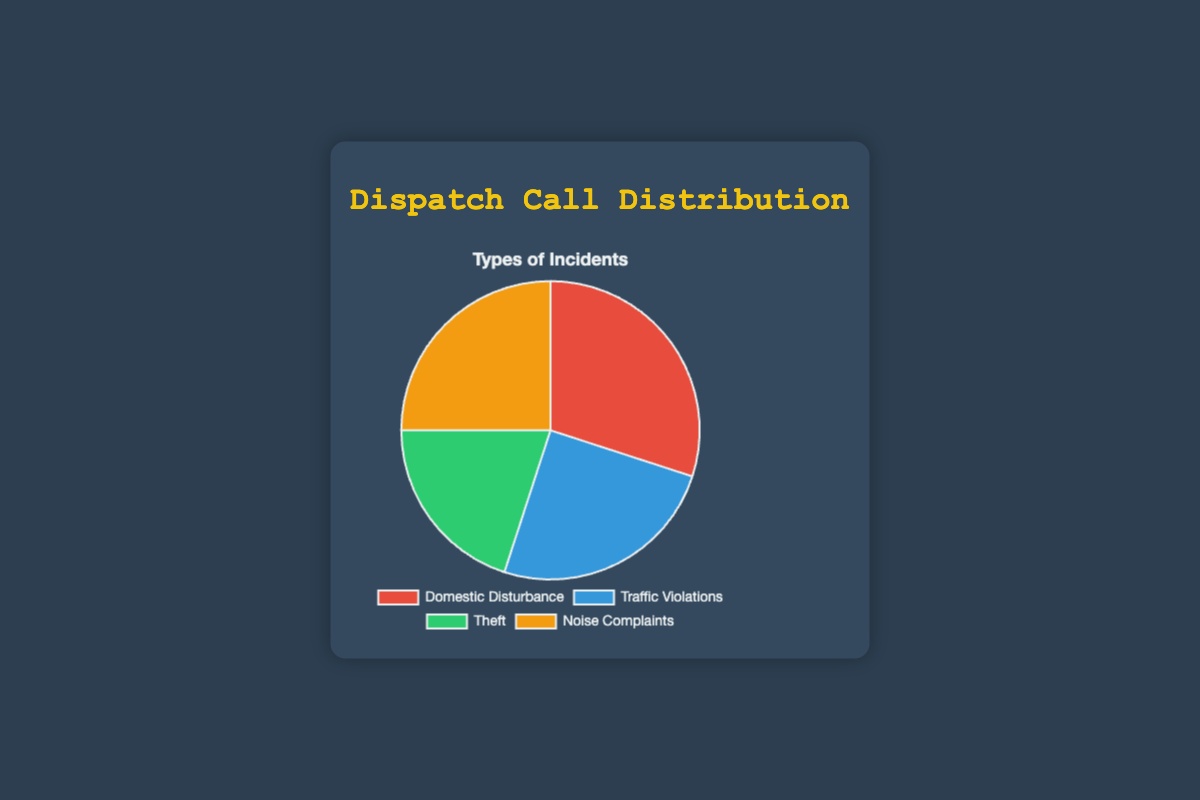Which incident type has the highest percentage of calls? Look at the pie chart and identify the incident type with the largest section. The 'Domestic Disturbance' section is the largest.
Answer: Domestic Disturbance Which two incident types have the same percentage of calls? Look at the pie chart and identify sections of equal size. 'Traffic Violations' and 'Noise Complaints' have the same percentages.
Answer: Traffic Violations and Noise Complaints What's the total percentage of calls attributed to Domestic Disturbance and Theft? Add the percentages for 'Domestic Disturbance' and 'Theft': 30% + 20% = 50%.
Answer: 50% How many more percentage points do Domestic Disturbance calls have compared to Theft calls? Subtract the percentage for 'Theft' from 'Domestic Disturbance': 30% - 20% = 10%.
Answer: 10 Which section is colored red? Observe the coloration of the pie chart sections and identify which incident type matches the red color. 'Domestic Disturbance' is colored red.
Answer: Domestic Disturbance Which incidents have a higher or equal percentage compared to Traffic Violations? Identify the incidents with percentages greater than or equal to 25%. 'Domestic Disturbance', 'Noise Complaints', and 'Traffic Violations' meet this criteria.
Answer: Domestic Disturbance, Noise Complaints What's the average percentage of calls for Noise Complaints and Traffic Violations combined? Add the percentages for 'Noise Complaints' and 'Traffic Violations' and divide by 2: (25% + 25%) / 2 = 25%.
Answer: 25 Which incident type is represented by the green color? Look at the pie chart's color coding and identify which incident type matches the green color. 'Theft' is represented by the green color.
Answer: Theft 